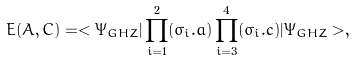Convert formula to latex. <formula><loc_0><loc_0><loc_500><loc_500>E ( A , C ) = < \Psi _ { G H Z } | \prod _ { i = 1 } ^ { 2 } ( \sigma _ { i } . { a } ) \prod _ { i = 3 } ^ { 4 } ( \sigma _ { i } . { c } ) | \Psi _ { G H Z } > ,</formula> 